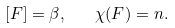<formula> <loc_0><loc_0><loc_500><loc_500>[ F ] = \beta , \quad \chi ( F ) = n .</formula> 